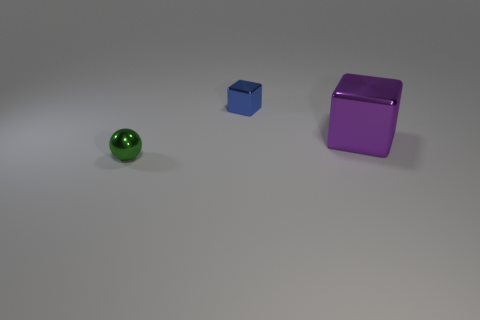How many rubber things are blocks or red balls?
Provide a succinct answer. 0. The thing that is right of the metal thing that is behind the large shiny cube is what color?
Make the answer very short. Purple. Is the material of the blue object the same as the object that is to the left of the small block?
Your response must be concise. Yes. The small thing that is in front of the shiny cube to the right of the small object that is behind the large shiny cube is what color?
Your answer should be compact. Green. Is there any other thing that is the same shape as the tiny green thing?
Your response must be concise. No. Is the number of tiny things greater than the number of metal objects?
Offer a very short reply. No. What number of things are in front of the blue cube and on the right side of the green metallic sphere?
Keep it short and to the point. 1. There is a tiny metal thing behind the small metallic ball; how many cubes are behind it?
Your answer should be very brief. 0. Does the object that is on the left side of the small cube have the same size as the metal object that is behind the large purple metal thing?
Provide a short and direct response. Yes. What number of small gray shiny balls are there?
Your answer should be compact. 0. 